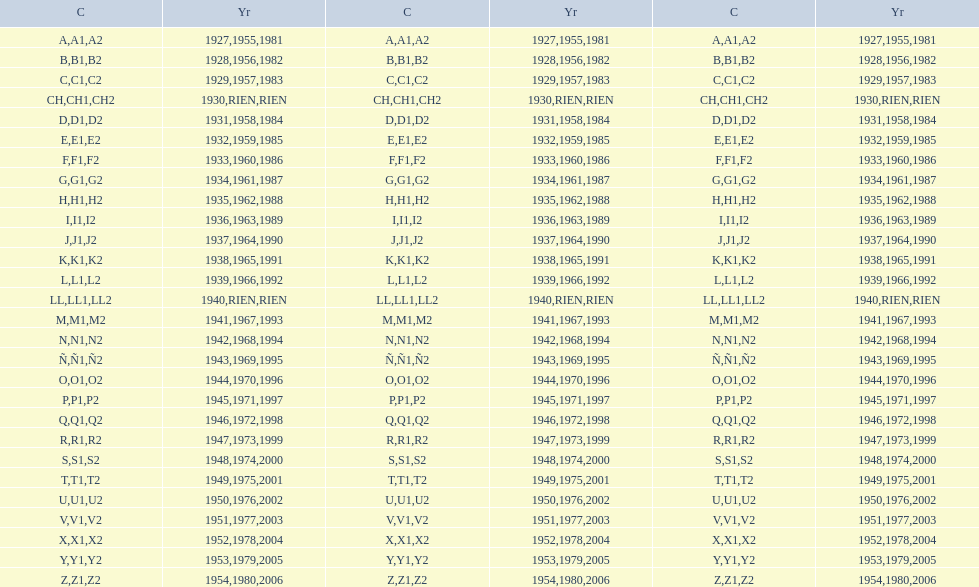How many different codes were used from 1953 to 1958? 6. 